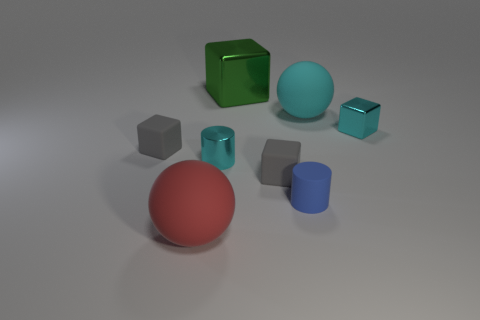What could be the purpose of such an arrangement of different geometric shapes and materials? This image could serve as a visual aid for educational purposes, explaining the concepts of geometry, materials science, or lighting in photography. It can also be useful for graphic design or 3D modeling tutorials that teach about object composition, texturing, and the effects of different lighting setups on various surfaces. 